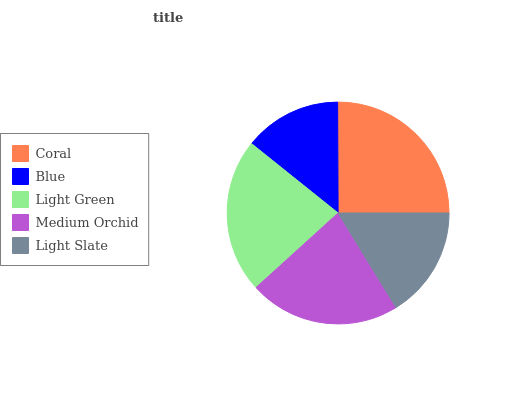Is Blue the minimum?
Answer yes or no. Yes. Is Coral the maximum?
Answer yes or no. Yes. Is Light Green the minimum?
Answer yes or no. No. Is Light Green the maximum?
Answer yes or no. No. Is Light Green greater than Blue?
Answer yes or no. Yes. Is Blue less than Light Green?
Answer yes or no. Yes. Is Blue greater than Light Green?
Answer yes or no. No. Is Light Green less than Blue?
Answer yes or no. No. Is Medium Orchid the high median?
Answer yes or no. Yes. Is Medium Orchid the low median?
Answer yes or no. Yes. Is Light Green the high median?
Answer yes or no. No. Is Light Slate the low median?
Answer yes or no. No. 